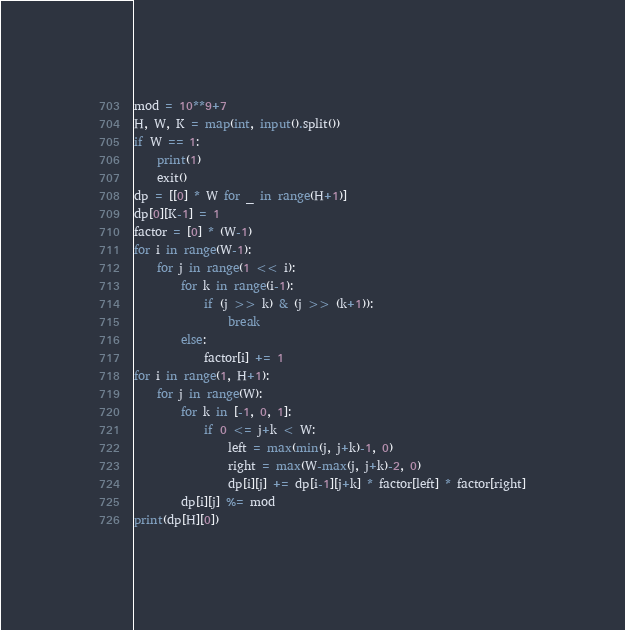Convert code to text. <code><loc_0><loc_0><loc_500><loc_500><_Python_>mod = 10**9+7
H, W, K = map(int, input().split())
if W == 1:
    print(1)
    exit()
dp = [[0] * W for _ in range(H+1)]
dp[0][K-1] = 1
factor = [0] * (W-1)
for i in range(W-1):
    for j in range(1 << i):
        for k in range(i-1):
            if (j >> k) & (j >> (k+1)):
                break
        else:
            factor[i] += 1
for i in range(1, H+1):
    for j in range(W):
        for k in [-1, 0, 1]:
            if 0 <= j+k < W:
                left = max(min(j, j+k)-1, 0)
                right = max(W-max(j, j+k)-2, 0)
                dp[i][j] += dp[i-1][j+k] * factor[left] * factor[right]
        dp[i][j] %= mod
print(dp[H][0])
</code> 